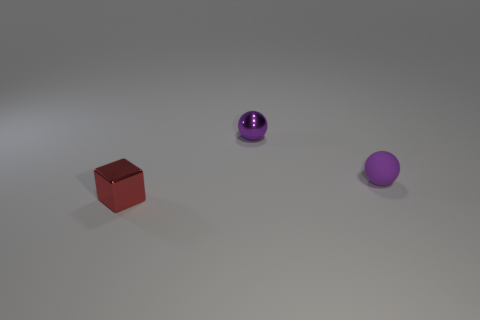Are there any other things that have the same shape as the red shiny thing?
Your answer should be very brief. No. There is a purple thing left of the rubber sphere; what size is it?
Make the answer very short. Small. How big is the red metallic object?
Make the answer very short. Small. What is the size of the object in front of the purple object that is in front of the tiny metal object that is behind the tiny red object?
Ensure brevity in your answer.  Small. Are there any purple spheres that have the same material as the red thing?
Your answer should be compact. Yes. What is the shape of the purple metal object?
Provide a short and direct response. Sphere. How many red things are either cubes or small objects?
Provide a short and direct response. 1. Are there more large blue metallic objects than tiny purple shiny balls?
Offer a very short reply. No. How many things are metallic objects on the right side of the small red object or small metallic objects right of the small metallic block?
Offer a very short reply. 1. What color is the matte thing that is the same size as the purple metallic sphere?
Provide a succinct answer. Purple. 